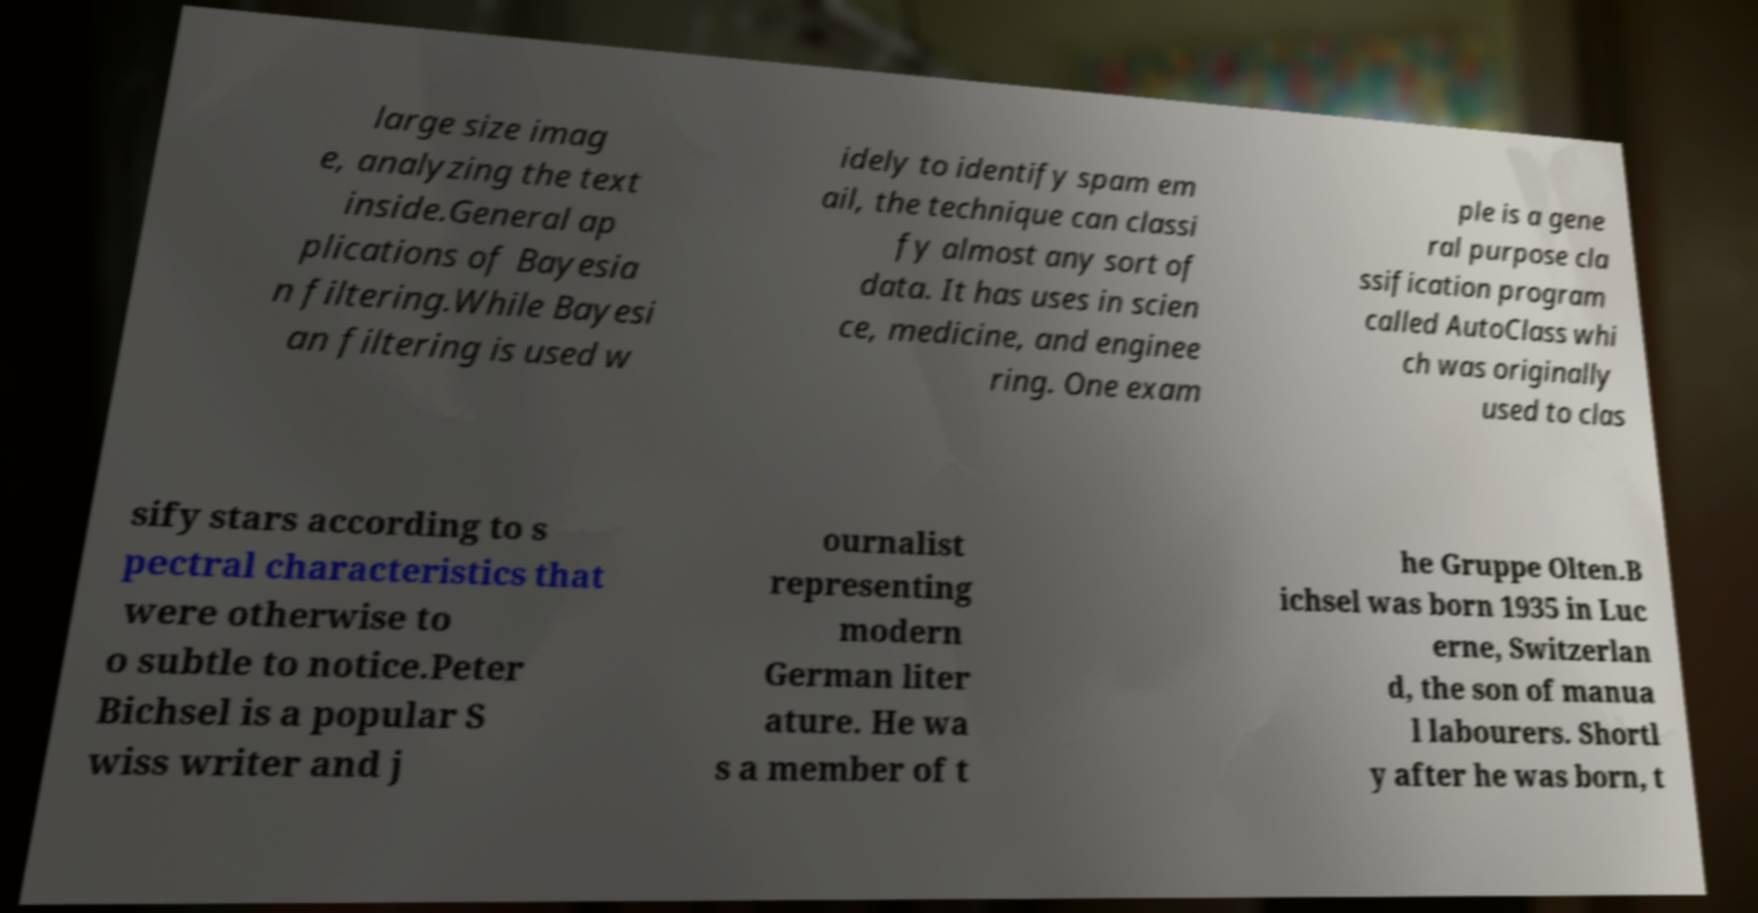Could you extract and type out the text from this image? large size imag e, analyzing the text inside.General ap plications of Bayesia n filtering.While Bayesi an filtering is used w idely to identify spam em ail, the technique can classi fy almost any sort of data. It has uses in scien ce, medicine, and enginee ring. One exam ple is a gene ral purpose cla ssification program called AutoClass whi ch was originally used to clas sify stars according to s pectral characteristics that were otherwise to o subtle to notice.Peter Bichsel is a popular S wiss writer and j ournalist representing modern German liter ature. He wa s a member of t he Gruppe Olten.B ichsel was born 1935 in Luc erne, Switzerlan d, the son of manua l labourers. Shortl y after he was born, t 